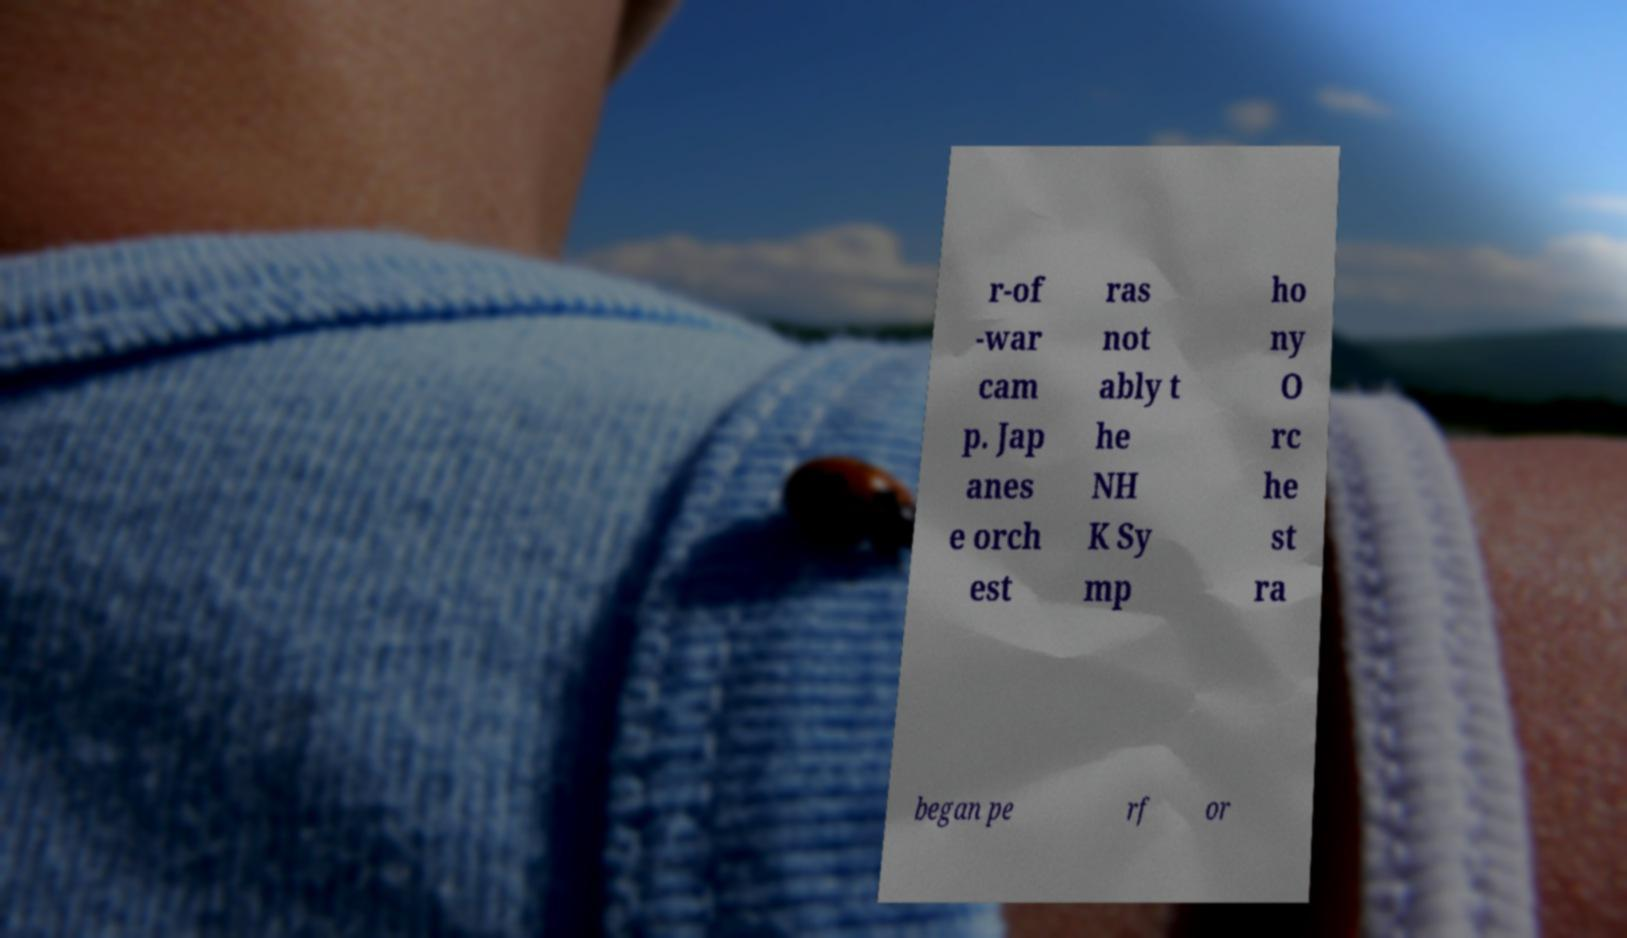What messages or text are displayed in this image? I need them in a readable, typed format. r-of -war cam p. Jap anes e orch est ras not ably t he NH K Sy mp ho ny O rc he st ra began pe rf or 